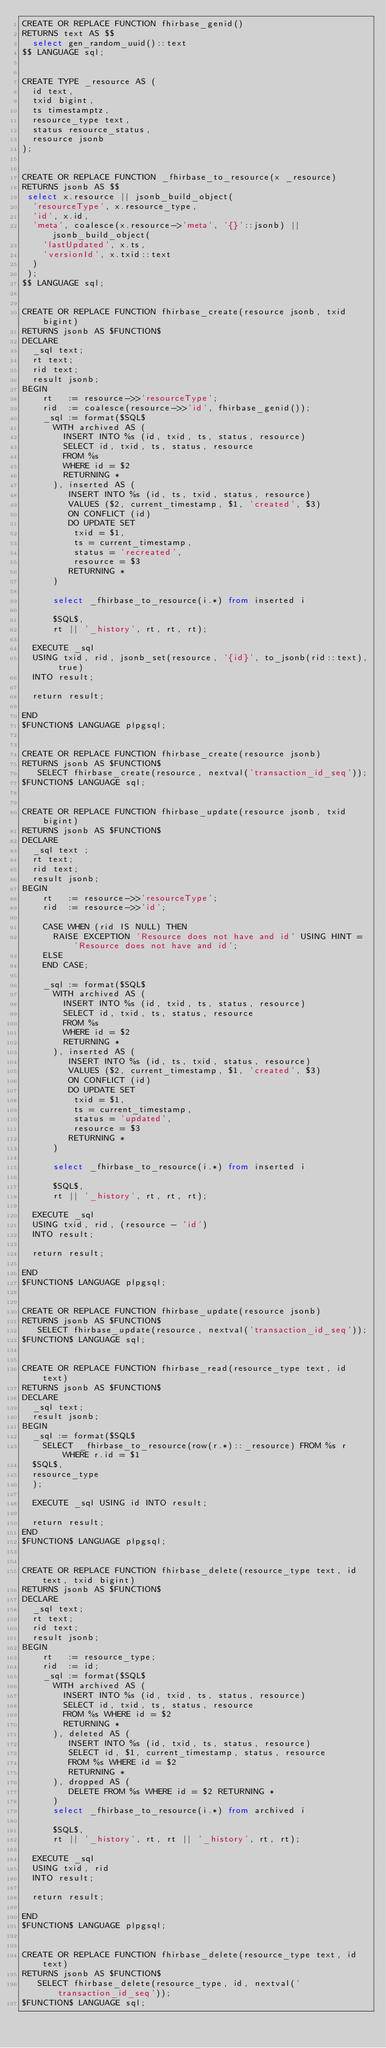<code> <loc_0><loc_0><loc_500><loc_500><_SQL_>CREATE OR REPLACE FUNCTION fhirbase_genid()
RETURNS text AS $$
  select gen_random_uuid()::text
$$ LANGUAGE sql;


CREATE TYPE _resource AS (
  id text,
  txid bigint,
  ts timestamptz,
  resource_type text,
  status resource_status,
  resource jsonb
);


CREATE OR REPLACE FUNCTION _fhirbase_to_resource(x _resource)
RETURNS jsonb AS $$
 select x.resource || jsonb_build_object(
  'resourceType', x.resource_type,
  'id', x.id,
  'meta', coalesce(x.resource->'meta', '{}'::jsonb) || jsonb_build_object(
    'lastUpdated', x.ts,
    'versionId', x.txid::text
  )
 );
$$ LANGUAGE sql;


CREATE OR REPLACE FUNCTION fhirbase_create(resource jsonb, txid bigint)
RETURNS jsonb AS $FUNCTION$
DECLARE
  _sql text;
  rt text;
  rid text;
  result jsonb;
BEGIN
    rt   := resource->>'resourceType';
    rid  := coalesce(resource->>'id', fhirbase_genid());
    _sql := format($SQL$
      WITH archived AS (
        INSERT INTO %s (id, txid, ts, status, resource)
        SELECT id, txid, ts, status, resource
        FROM %s
        WHERE id = $2
        RETURNING *
      ), inserted AS (
         INSERT INTO %s (id, ts, txid, status, resource)
         VALUES ($2, current_timestamp, $1, 'created', $3)
         ON CONFLICT (id)
         DO UPDATE SET
          txid = $1,
          ts = current_timestamp,
          status = 'recreated',
          resource = $3
         RETURNING *
      )

      select _fhirbase_to_resource(i.*) from inserted i

      $SQL$,
      rt || '_history', rt, rt, rt);

  EXECUTE _sql
  USING txid, rid, jsonb_set(resource, '{id}', to_jsonb(rid::text), true)
  INTO result;

  return result;

END
$FUNCTION$ LANGUAGE plpgsql;


CREATE OR REPLACE FUNCTION fhirbase_create(resource jsonb)
RETURNS jsonb AS $FUNCTION$
   SELECT fhirbase_create(resource, nextval('transaction_id_seq'));
$FUNCTION$ LANGUAGE sql;


CREATE OR REPLACE FUNCTION fhirbase_update(resource jsonb, txid bigint)
RETURNS jsonb AS $FUNCTION$
DECLARE
  _sql text ;
  rt text;
  rid text;
  result jsonb;
BEGIN
    rt   := resource->>'resourceType';
    rid  := resource->>'id';

    CASE WHEN (rid IS NULL) THEN
      RAISE EXCEPTION 'Resource does not have and id' USING HINT = 'Resource does not have and id';
    ELSE
    END CASE;

    _sql := format($SQL$
      WITH archived AS (
        INSERT INTO %s (id, txid, ts, status, resource)
        SELECT id, txid, ts, status, resource
        FROM %s
        WHERE id = $2
        RETURNING *
      ), inserted AS (
         INSERT INTO %s (id, ts, txid, status, resource)
         VALUES ($2, current_timestamp, $1, 'created', $3)
         ON CONFLICT (id)
         DO UPDATE SET
          txid = $1,
          ts = current_timestamp,
          status = 'updated',
          resource = $3
         RETURNING *
      )

      select _fhirbase_to_resource(i.*) from inserted i

      $SQL$,
      rt || '_history', rt, rt, rt);

  EXECUTE _sql
  USING txid, rid, (resource - 'id')
  INTO result;

  return result;

END
$FUNCTION$ LANGUAGE plpgsql;


CREATE OR REPLACE FUNCTION fhirbase_update(resource jsonb)
RETURNS jsonb AS $FUNCTION$
   SELECT fhirbase_update(resource, nextval('transaction_id_seq'));
$FUNCTION$ LANGUAGE sql;


CREATE OR REPLACE FUNCTION fhirbase_read(resource_type text, id text)
RETURNS jsonb AS $FUNCTION$
DECLARE
  _sql text;
  result jsonb;
BEGIN
  _sql := format($SQL$
    SELECT _fhirbase_to_resource(row(r.*)::_resource) FROM %s r WHERE r.id = $1
  $SQL$,
  resource_type
  );

  EXECUTE _sql USING id INTO result;

  return result;
END
$FUNCTION$ LANGUAGE plpgsql;


CREATE OR REPLACE FUNCTION fhirbase_delete(resource_type text, id text, txid bigint)
RETURNS jsonb AS $FUNCTION$
DECLARE
  _sql text;
  rt text;
  rid text;
  result jsonb;
BEGIN
    rt   := resource_type;
    rid  := id;
    _sql := format($SQL$
      WITH archived AS (
        INSERT INTO %s (id, txid, ts, status, resource)
        SELECT id, txid, ts, status, resource
        FROM %s WHERE id = $2
        RETURNING *
      ), deleted AS (
         INSERT INTO %s (id, txid, ts, status, resource)
         SELECT id, $1, current_timestamp, status, resource
         FROM %s WHERE id = $2
         RETURNING *
      ), dropped AS (
         DELETE FROM %s WHERE id = $2 RETURNING *
      )
      select _fhirbase_to_resource(i.*) from archived i

      $SQL$,
      rt || '_history', rt, rt || '_history', rt, rt);

  EXECUTE _sql
  USING txid, rid
  INTO result;

  return result;

END
$FUNCTION$ LANGUAGE plpgsql;


CREATE OR REPLACE FUNCTION fhirbase_delete(resource_type text, id text)
RETURNS jsonb AS $FUNCTION$
   SELECT fhirbase_delete(resource_type, id, nextval('transaction_id_seq'));
$FUNCTION$ LANGUAGE sql;
</code> 